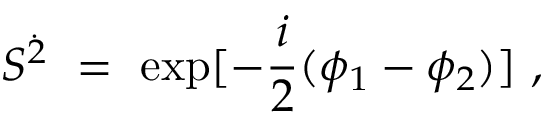Convert formula to latex. <formula><loc_0><loc_0><loc_500><loc_500>S ^ { \dot { 2 } } = e x p [ - \frac { i } { 2 } ( \phi _ { 1 } - \phi _ { 2 } ) ] ,</formula> 